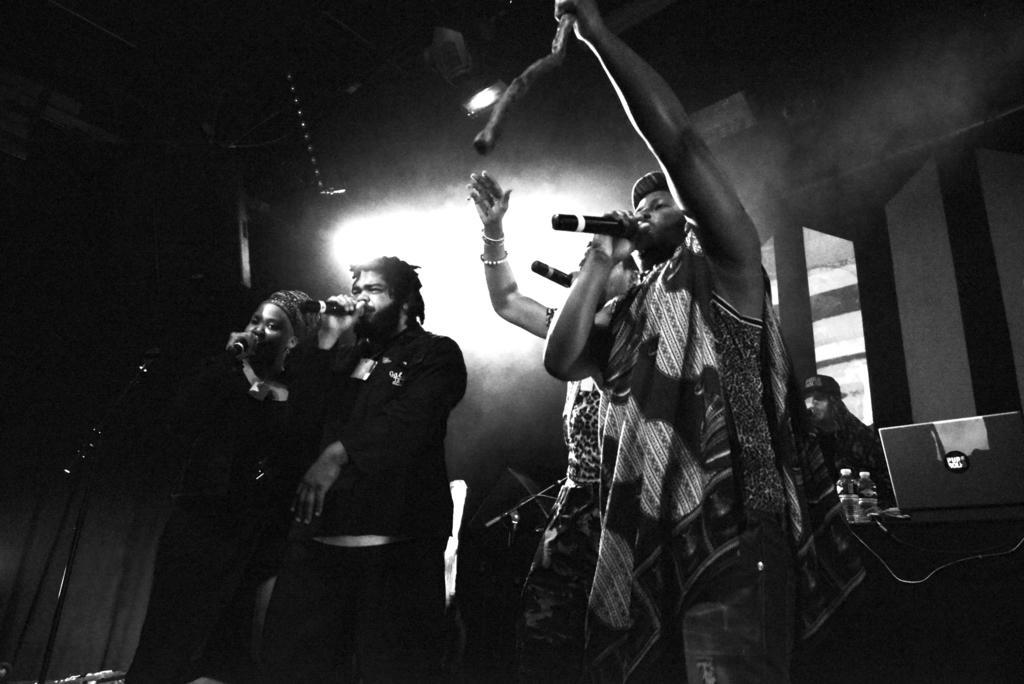How would you summarize this image in a sentence or two? A black and white picture. These persons are holding mics and singing. On this table there are bottles and laptop. 